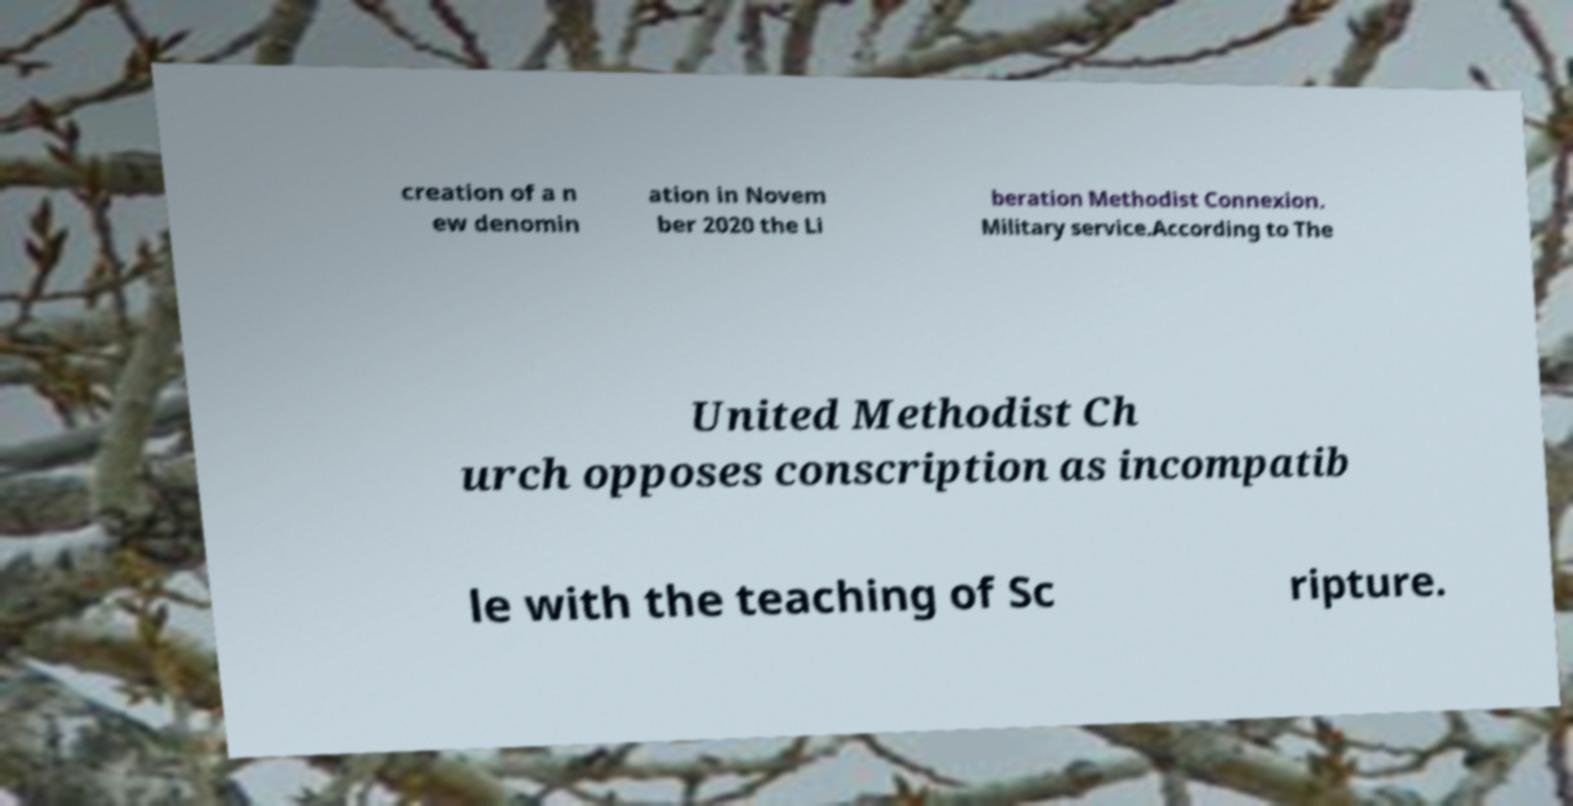What messages or text are displayed in this image? I need them in a readable, typed format. creation of a n ew denomin ation in Novem ber 2020 the Li beration Methodist Connexion. Military service.According to The United Methodist Ch urch opposes conscription as incompatib le with the teaching of Sc ripture. 